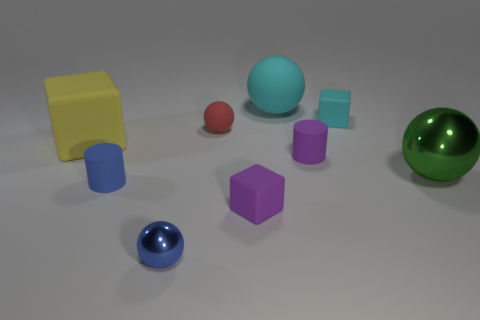Are there more metallic objects behind the tiny purple cube than large cyan metallic spheres?
Make the answer very short. Yes. How many tiny red matte spheres are in front of the small purple rubber cylinder?
Provide a short and direct response. 0. Are there any other rubber things that have the same size as the yellow thing?
Provide a succinct answer. Yes. What is the color of the other small object that is the same shape as the tiny cyan object?
Provide a succinct answer. Purple. There is a rubber block in front of the big yellow block; does it have the same size as the block to the right of the purple matte cylinder?
Your response must be concise. Yes. Are there any other tiny things of the same shape as the blue rubber thing?
Give a very brief answer. Yes. Is the number of small blue balls that are to the left of the blue ball the same as the number of large blue cylinders?
Offer a terse response. Yes. There is a blue shiny object; is its size the same as the block that is behind the big cube?
Ensure brevity in your answer.  Yes. What number of tiny balls are the same material as the small red thing?
Your answer should be compact. 0. Do the yellow rubber block and the green thing have the same size?
Your response must be concise. Yes. 